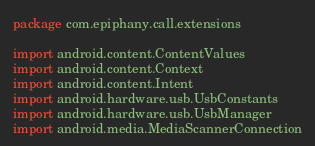<code> <loc_0><loc_0><loc_500><loc_500><_Kotlin_>package com.epiphany.call.extensions

import android.content.ContentValues
import android.content.Context
import android.content.Intent
import android.hardware.usb.UsbConstants
import android.hardware.usb.UsbManager
import android.media.MediaScannerConnection</code> 